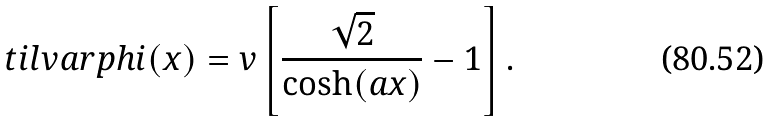<formula> <loc_0><loc_0><loc_500><loc_500>\ t i l v a r p h i ( x ) = v \left [ \frac { \sqrt { 2 } } { \cosh ( a x ) } - 1 \right ] .</formula> 